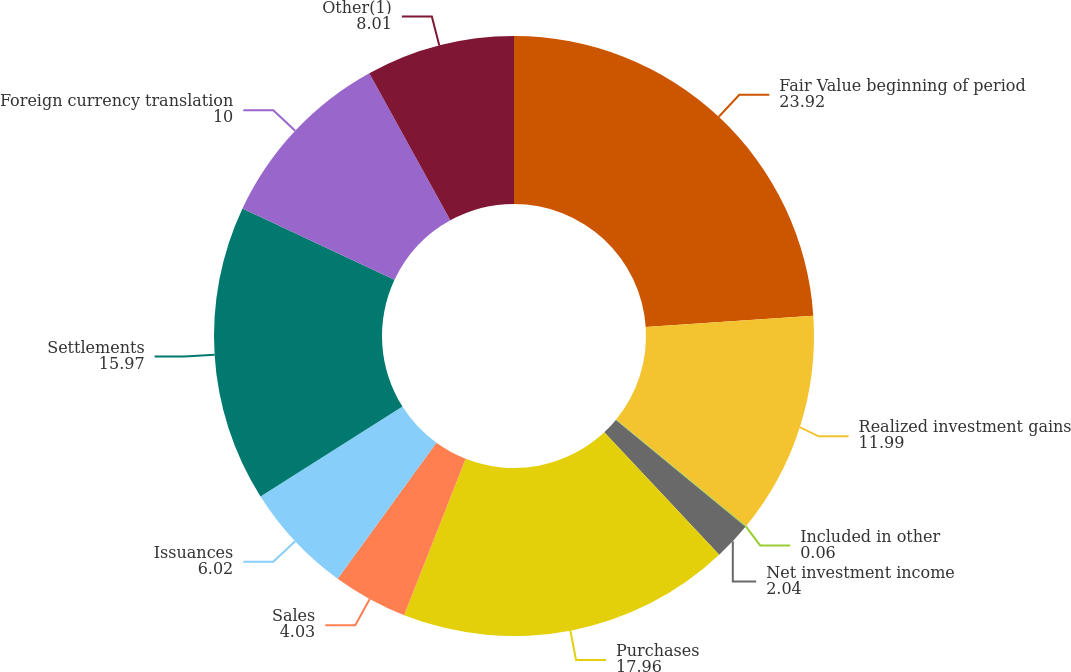Convert chart. <chart><loc_0><loc_0><loc_500><loc_500><pie_chart><fcel>Fair Value beginning of period<fcel>Realized investment gains<fcel>Included in other<fcel>Net investment income<fcel>Purchases<fcel>Sales<fcel>Issuances<fcel>Settlements<fcel>Foreign currency translation<fcel>Other(1)<nl><fcel>23.92%<fcel>11.99%<fcel>0.06%<fcel>2.04%<fcel>17.96%<fcel>4.03%<fcel>6.02%<fcel>15.97%<fcel>10.0%<fcel>8.01%<nl></chart> 